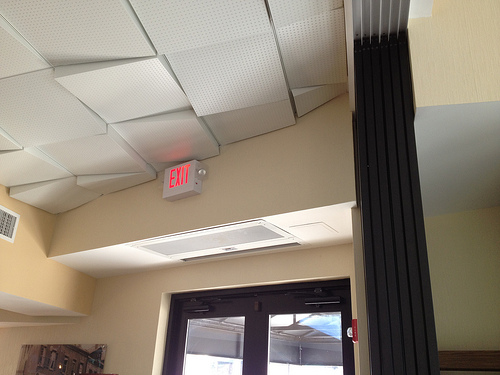<image>
Is the glass door under the exit sign? Yes. The glass door is positioned underneath the exit sign, with the exit sign above it in the vertical space. 